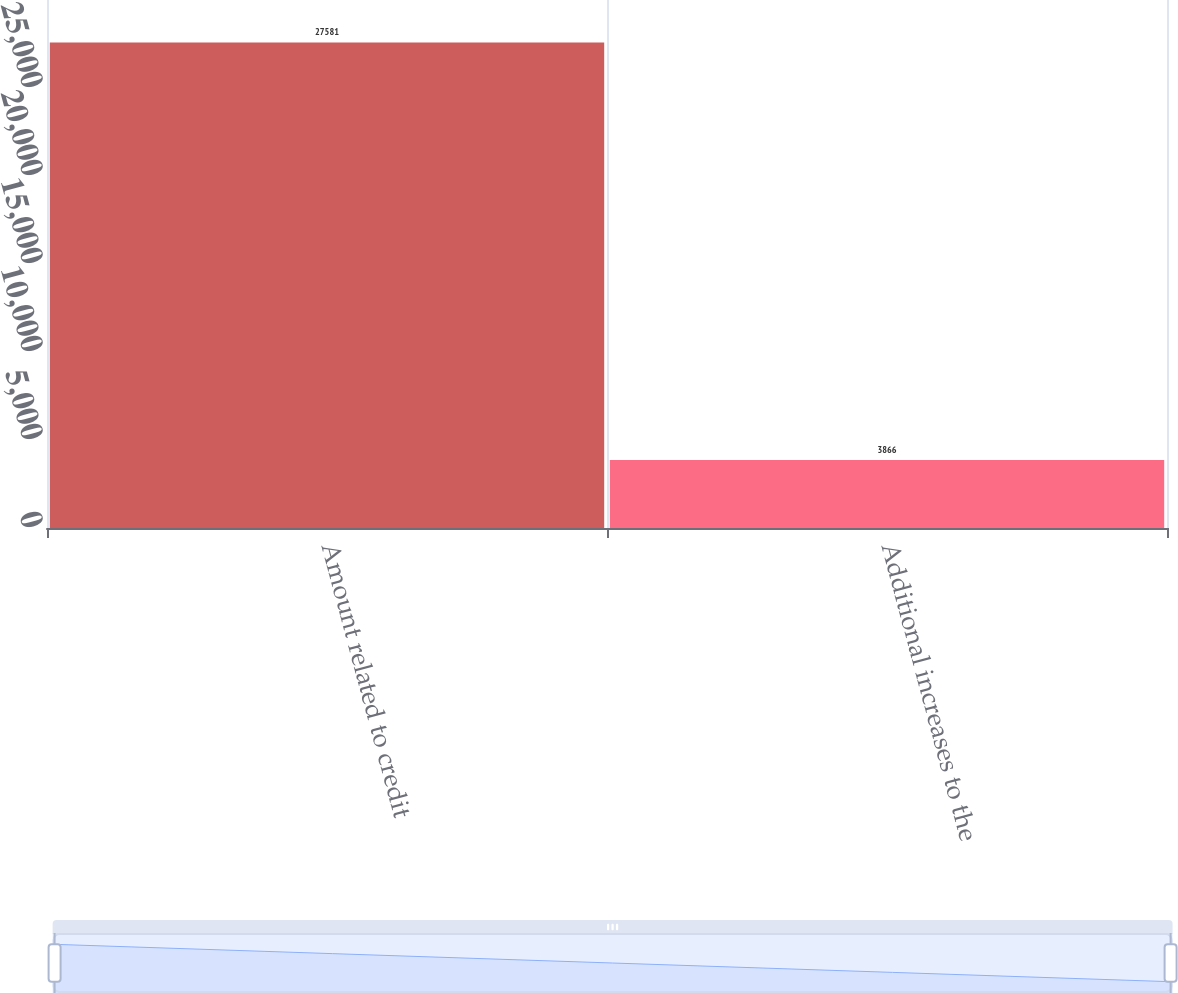<chart> <loc_0><loc_0><loc_500><loc_500><bar_chart><fcel>Amount related to credit<fcel>Additional increases to the<nl><fcel>27581<fcel>3866<nl></chart> 